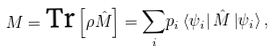<formula> <loc_0><loc_0><loc_500><loc_500>M = \text {Tr} \left [ \rho \hat { M } \right ] = \underset { i } { \sum } p _ { i } \left \langle \psi _ { i } \right | \hat { M } \left | \psi _ { i } \right \rangle ,</formula> 